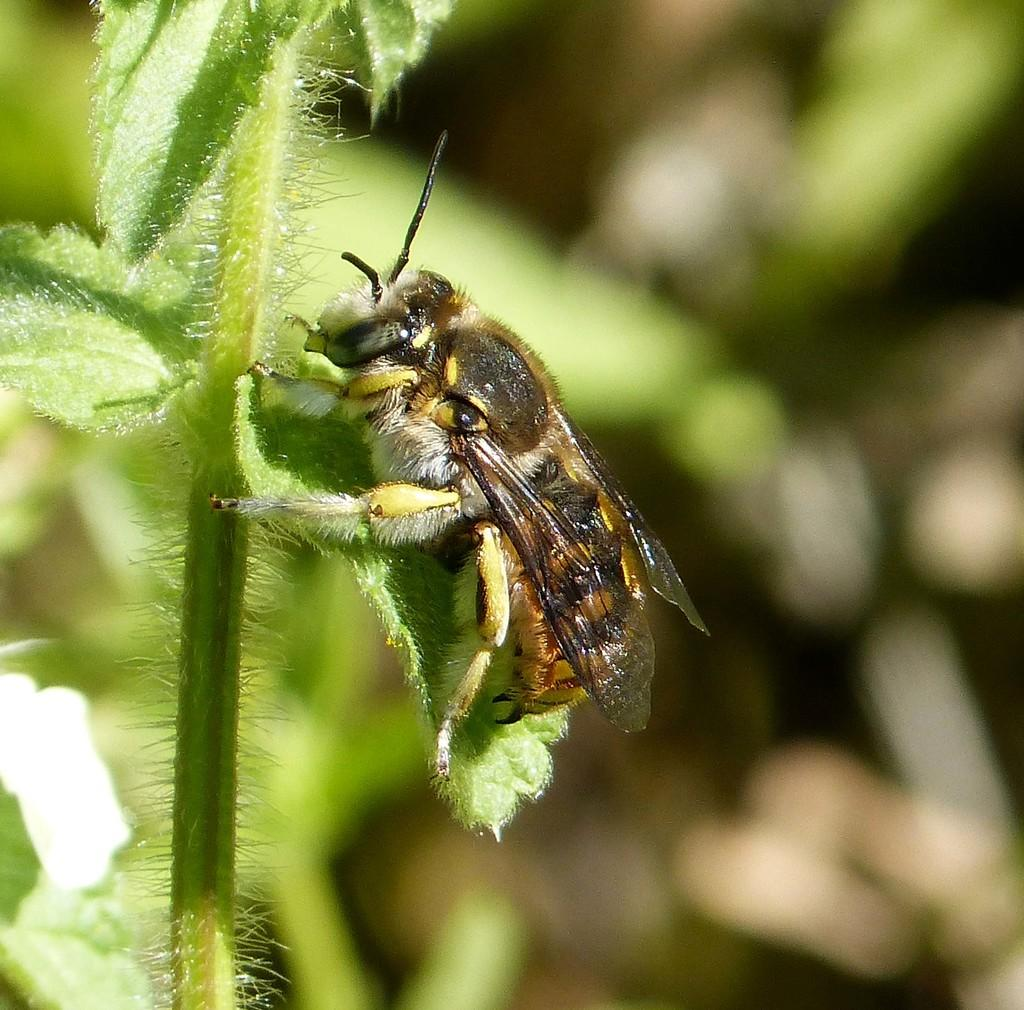What is present in the image? There is an insect in the image. Where is the insect located? The insect is on a plant. Can you describe the background of the image? The background of the image is blurred. What type of pear can be seen in the image? There is no pear present in the image; it features an insect on a plant. How many cars are visible in the image? There are no cars present in the image. 